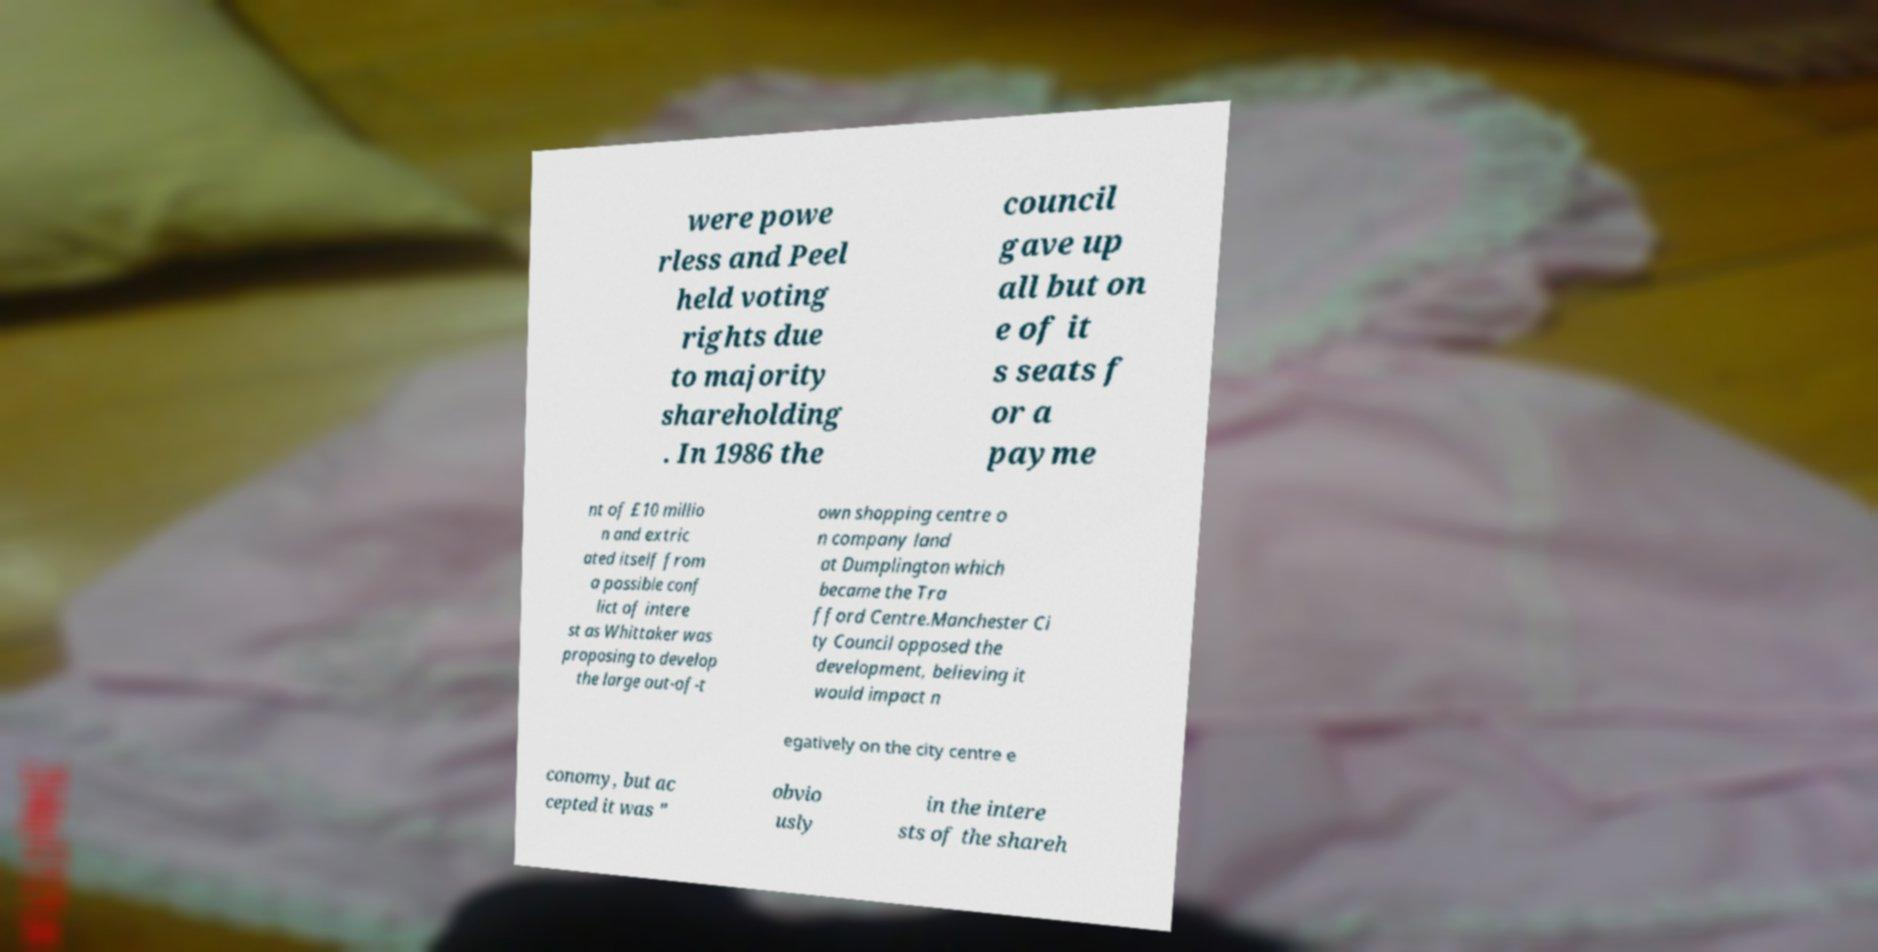Please read and relay the text visible in this image. What does it say? were powe rless and Peel held voting rights due to majority shareholding . In 1986 the council gave up all but on e of it s seats f or a payme nt of £10 millio n and extric ated itself from a possible conf lict of intere st as Whittaker was proposing to develop the large out-of-t own shopping centre o n company land at Dumplington which became the Tra fford Centre.Manchester Ci ty Council opposed the development, believing it would impact n egatively on the city centre e conomy, but ac cepted it was " obvio usly in the intere sts of the shareh 